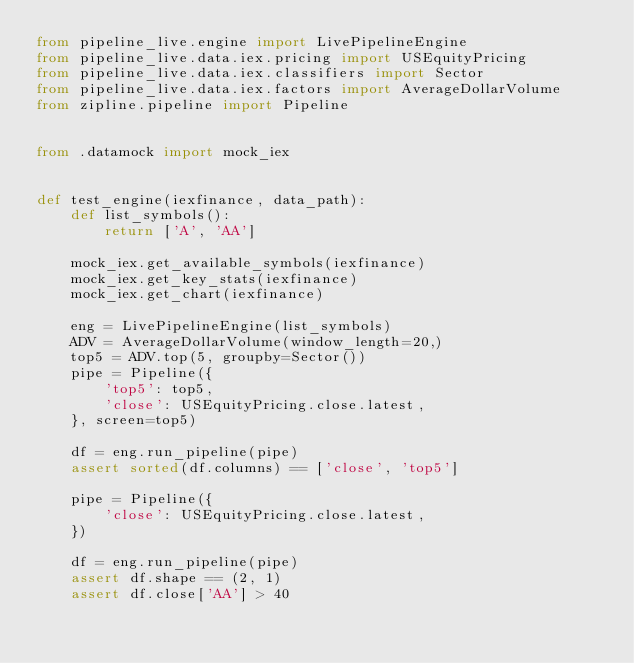<code> <loc_0><loc_0><loc_500><loc_500><_Python_>from pipeline_live.engine import LivePipelineEngine
from pipeline_live.data.iex.pricing import USEquityPricing
from pipeline_live.data.iex.classifiers import Sector
from pipeline_live.data.iex.factors import AverageDollarVolume
from zipline.pipeline import Pipeline


from .datamock import mock_iex


def test_engine(iexfinance, data_path):
    def list_symbols():
        return ['A', 'AA']

    mock_iex.get_available_symbols(iexfinance)
    mock_iex.get_key_stats(iexfinance)
    mock_iex.get_chart(iexfinance)

    eng = LivePipelineEngine(list_symbols)
    ADV = AverageDollarVolume(window_length=20,)
    top5 = ADV.top(5, groupby=Sector())
    pipe = Pipeline({
        'top5': top5,
        'close': USEquityPricing.close.latest,
    }, screen=top5)

    df = eng.run_pipeline(pipe)
    assert sorted(df.columns) == ['close', 'top5']

    pipe = Pipeline({
        'close': USEquityPricing.close.latest,
    })

    df = eng.run_pipeline(pipe)
    assert df.shape == (2, 1)
    assert df.close['AA'] > 40
</code> 